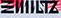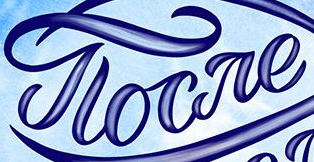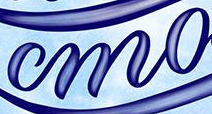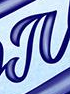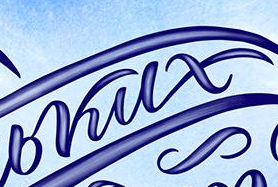What text appears in these images from left to right, separated by a semicolon? ΞIIIILTZ; gloare; mo; #; bkux 